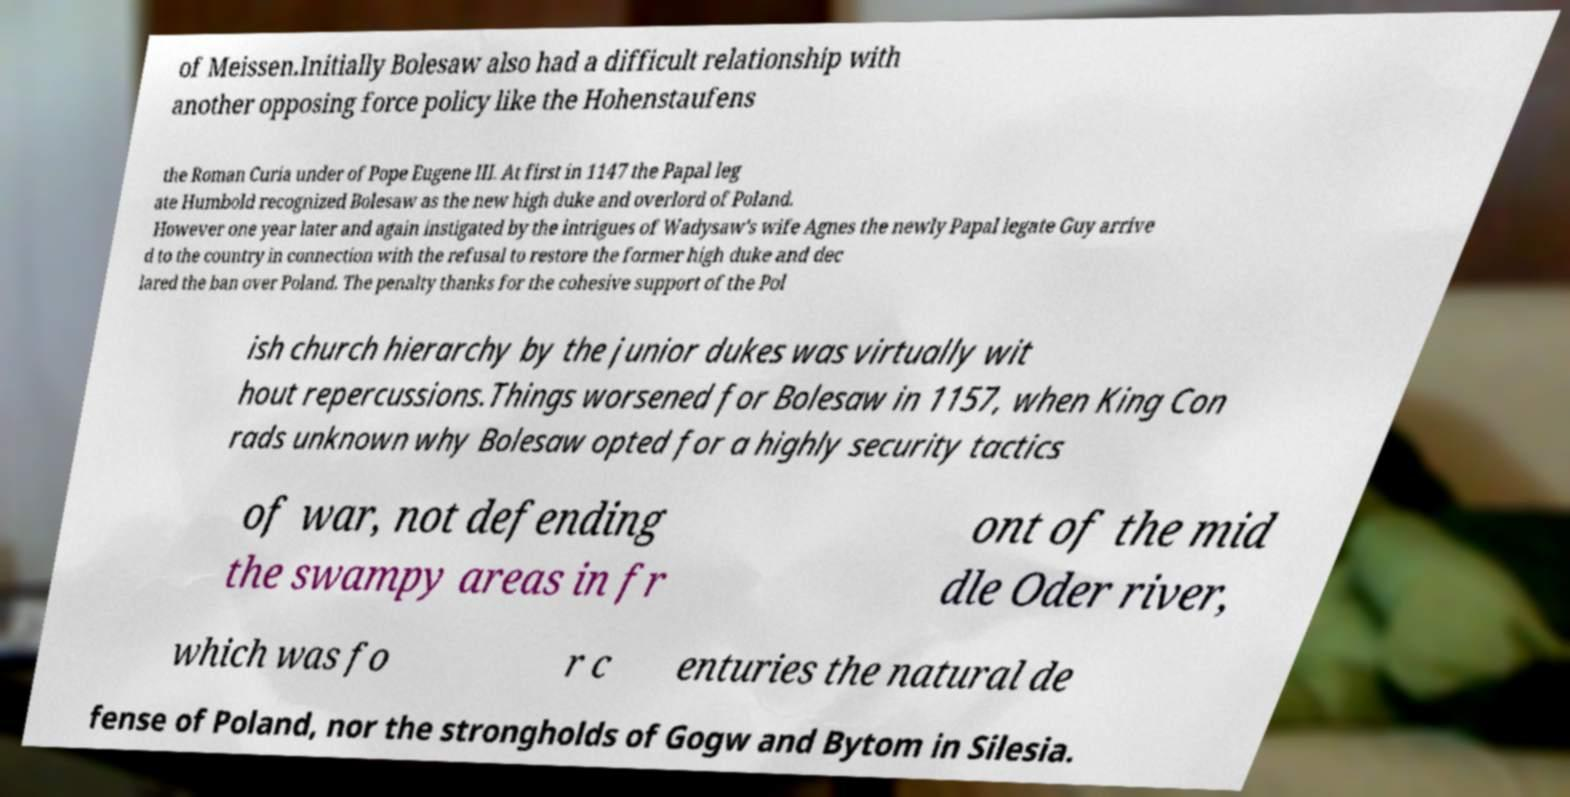Can you read and provide the text displayed in the image?This photo seems to have some interesting text. Can you extract and type it out for me? of Meissen.Initially Bolesaw also had a difficult relationship with another opposing force policy like the Hohenstaufens the Roman Curia under of Pope Eugene III. At first in 1147 the Papal leg ate Humbold recognized Bolesaw as the new high duke and overlord of Poland. However one year later and again instigated by the intrigues of Wadysaw's wife Agnes the newly Papal legate Guy arrive d to the country in connection with the refusal to restore the former high duke and dec lared the ban over Poland. The penalty thanks for the cohesive support of the Pol ish church hierarchy by the junior dukes was virtually wit hout repercussions.Things worsened for Bolesaw in 1157, when King Con rads unknown why Bolesaw opted for a highly security tactics of war, not defending the swampy areas in fr ont of the mid dle Oder river, which was fo r c enturies the natural de fense of Poland, nor the strongholds of Gogw and Bytom in Silesia. 